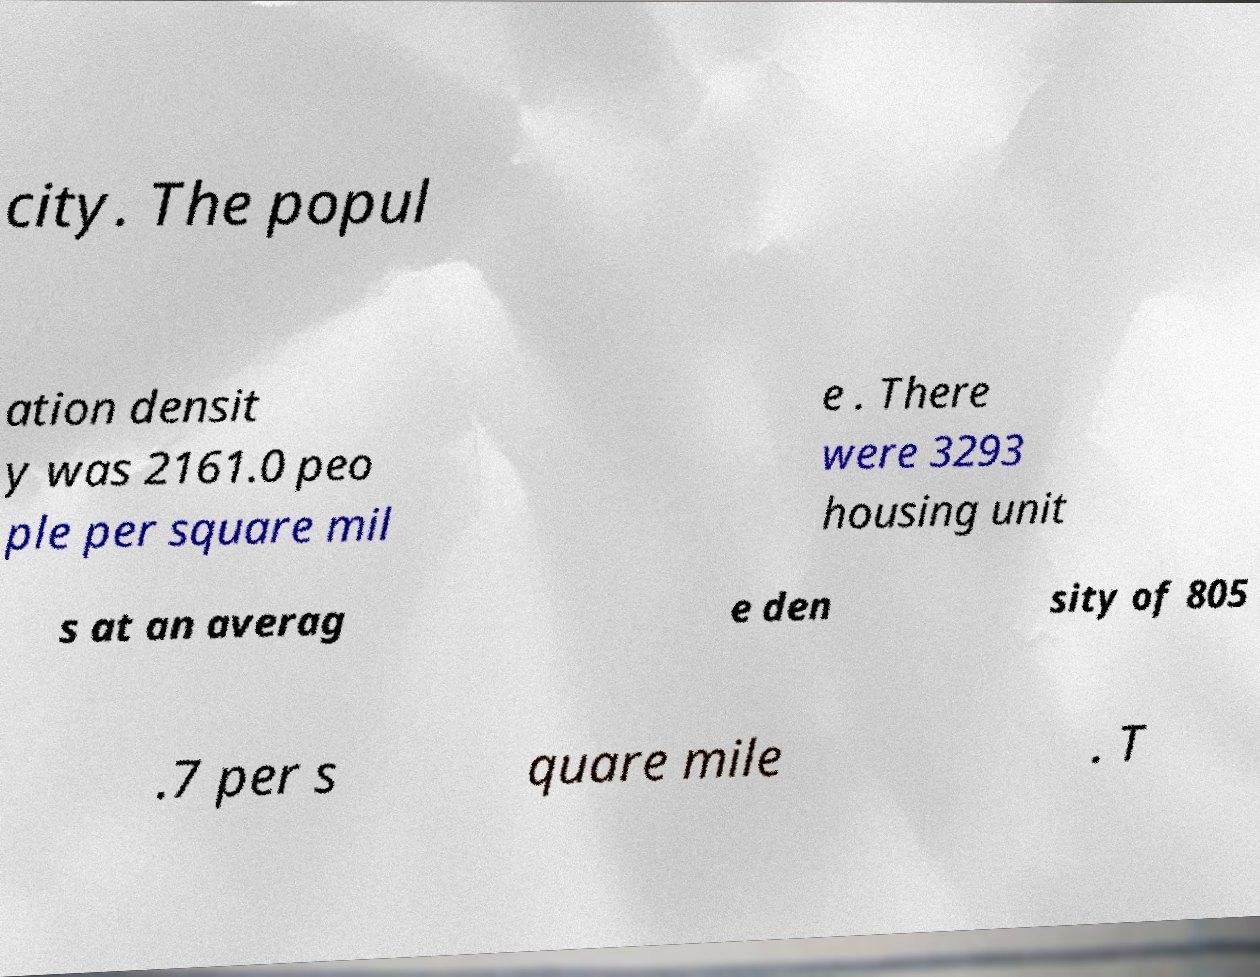I need the written content from this picture converted into text. Can you do that? city. The popul ation densit y was 2161.0 peo ple per square mil e . There were 3293 housing unit s at an averag e den sity of 805 .7 per s quare mile . T 